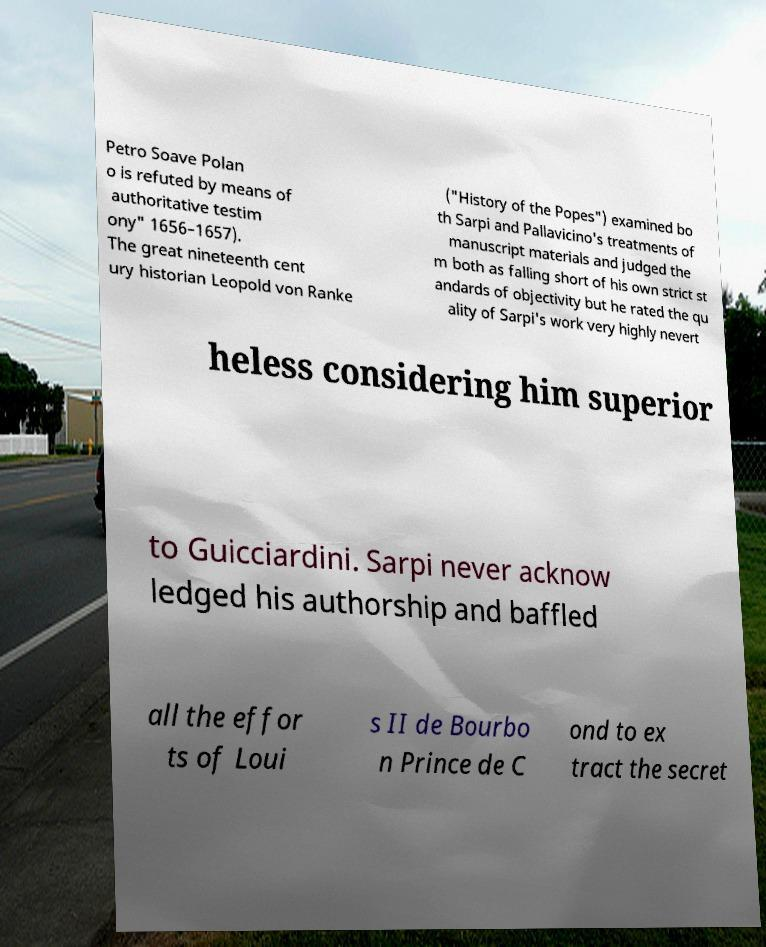I need the written content from this picture converted into text. Can you do that? Petro Soave Polan o is refuted by means of authoritative testim ony" 1656–1657). The great nineteenth cent ury historian Leopold von Ranke ("History of the Popes") examined bo th Sarpi and Pallavicino's treatments of manuscript materials and judged the m both as falling short of his own strict st andards of objectivity but he rated the qu ality of Sarpi's work very highly nevert heless considering him superior to Guicciardini. Sarpi never acknow ledged his authorship and baffled all the effor ts of Loui s II de Bourbo n Prince de C ond to ex tract the secret 